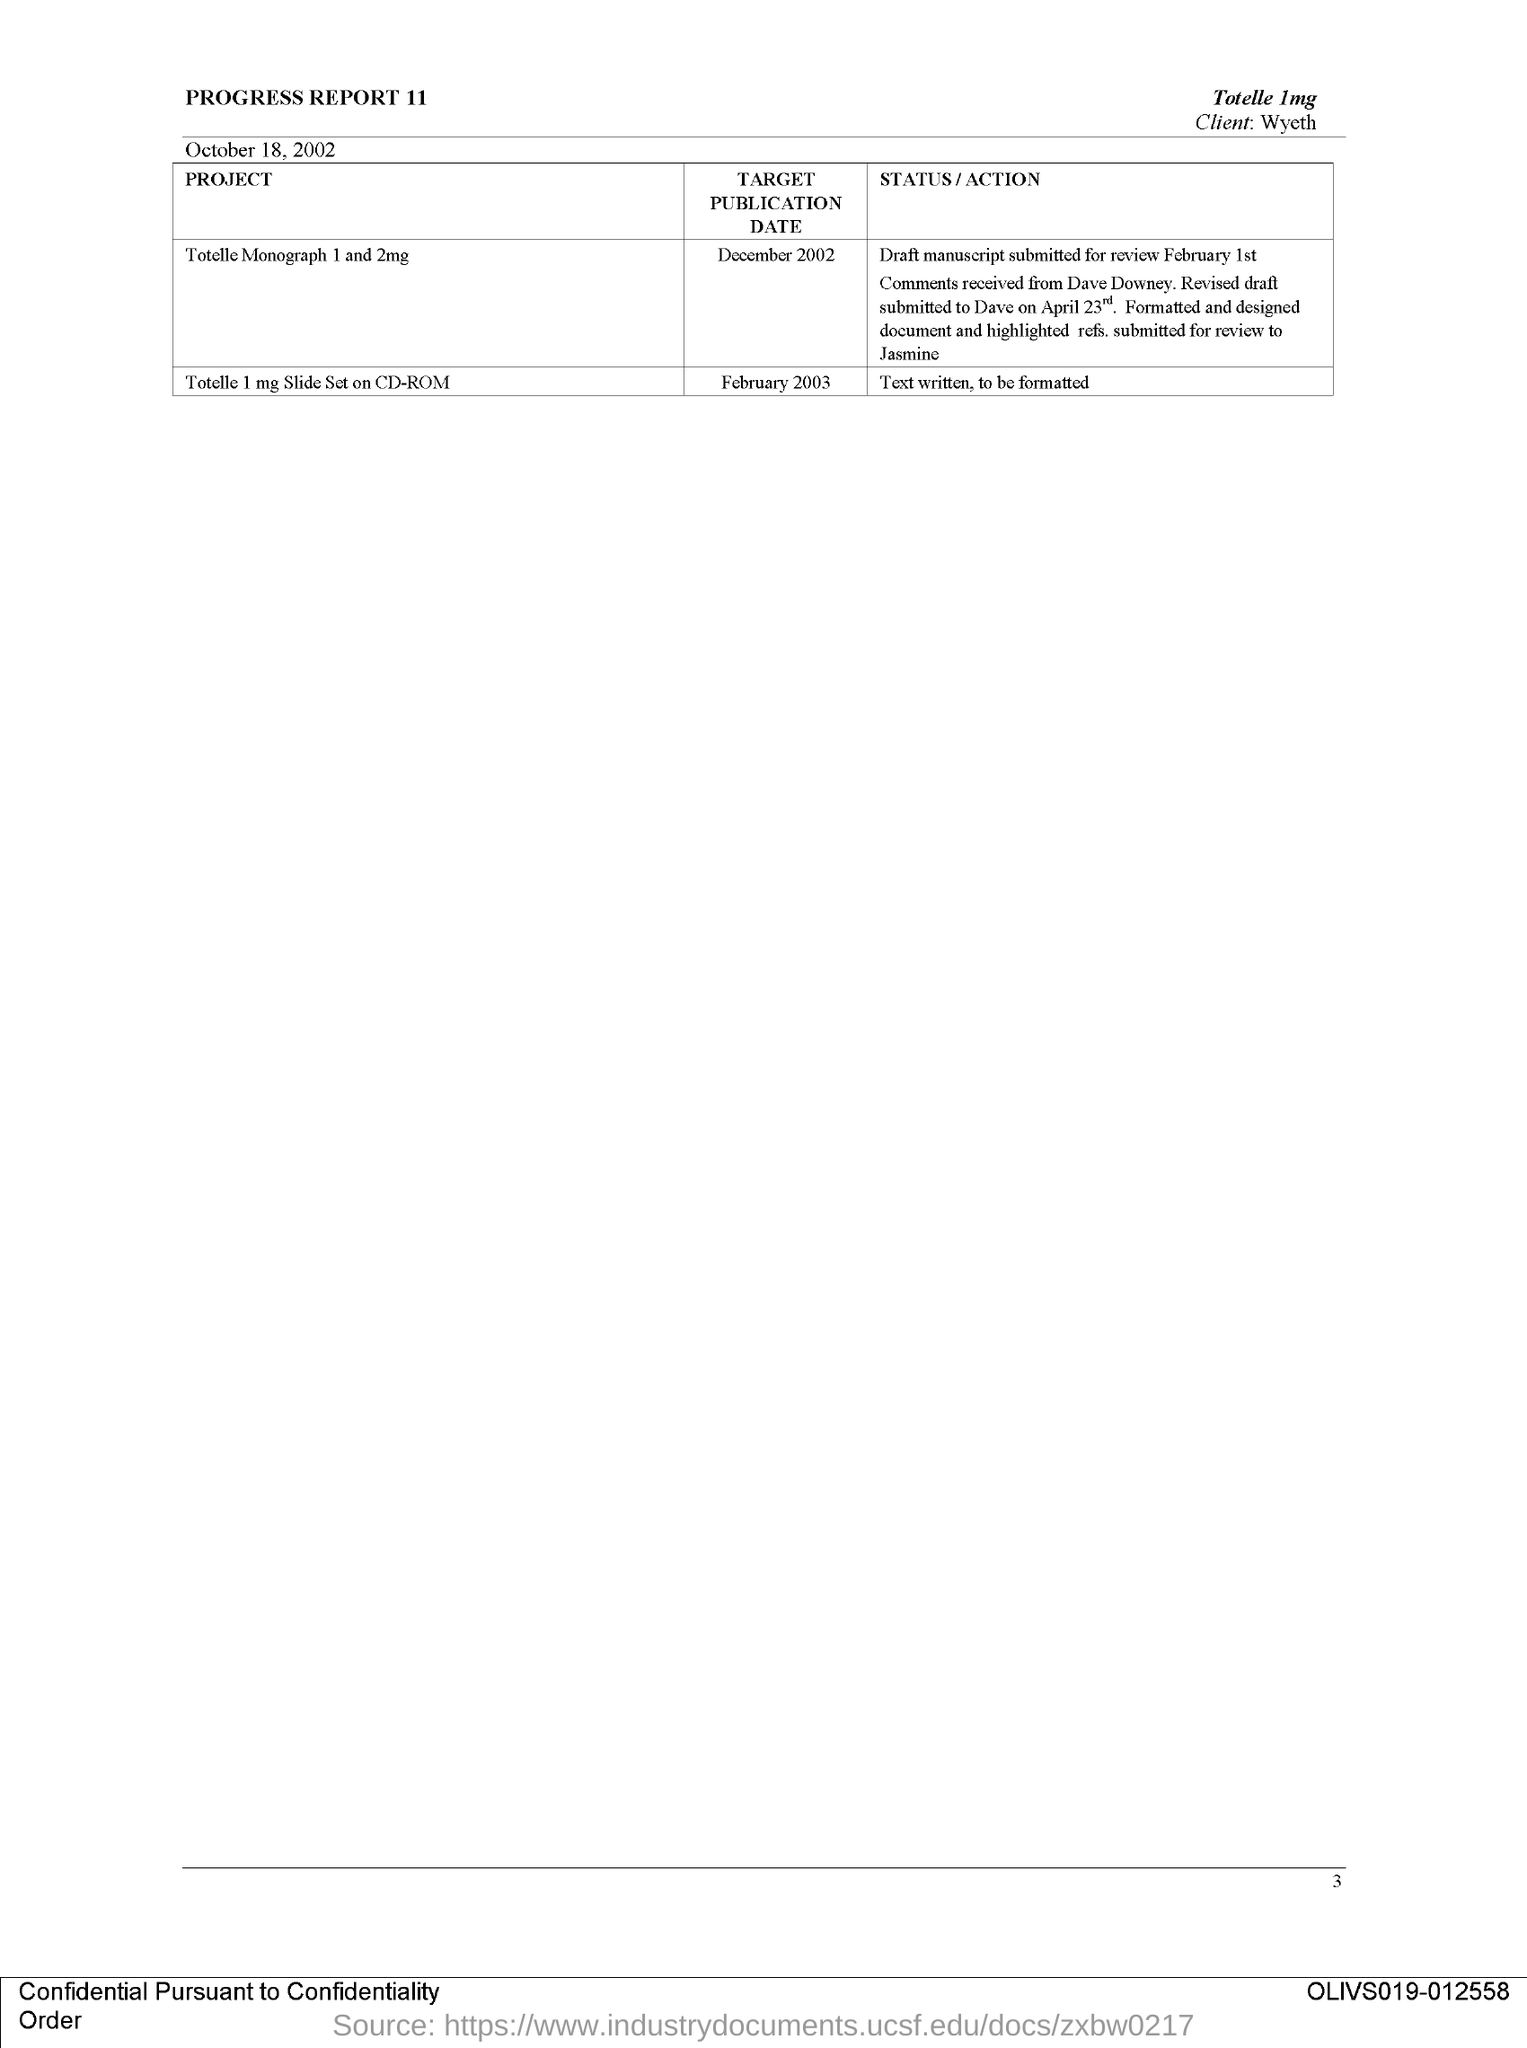What is the title of this document?
Make the answer very short. Progress Report 11. What is the issued date of this document?
Your answer should be very brief. October 18, 2002. What is the client name mentioned in this document?
Provide a succinct answer. Wyeth. What is the target publication date for the project titled 'Totelle Monograph 1 and 2mg'?
Keep it short and to the point. December 2002. What is the target publication date for the project titled 'Totelle 1 mg slide set on CD-ROM'?
Your answer should be very brief. February 2003. What is the status/action mentioned for the project titled ''Totelle 1 mg slide set on CD-ROM'?
Keep it short and to the point. Text written, to be formatted. 